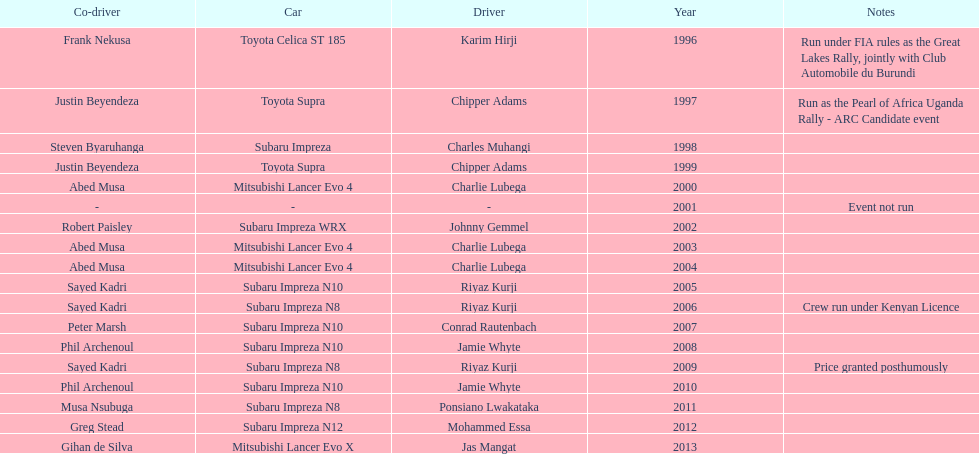How many drivers are racing with a co-driver from a different country? 1. 